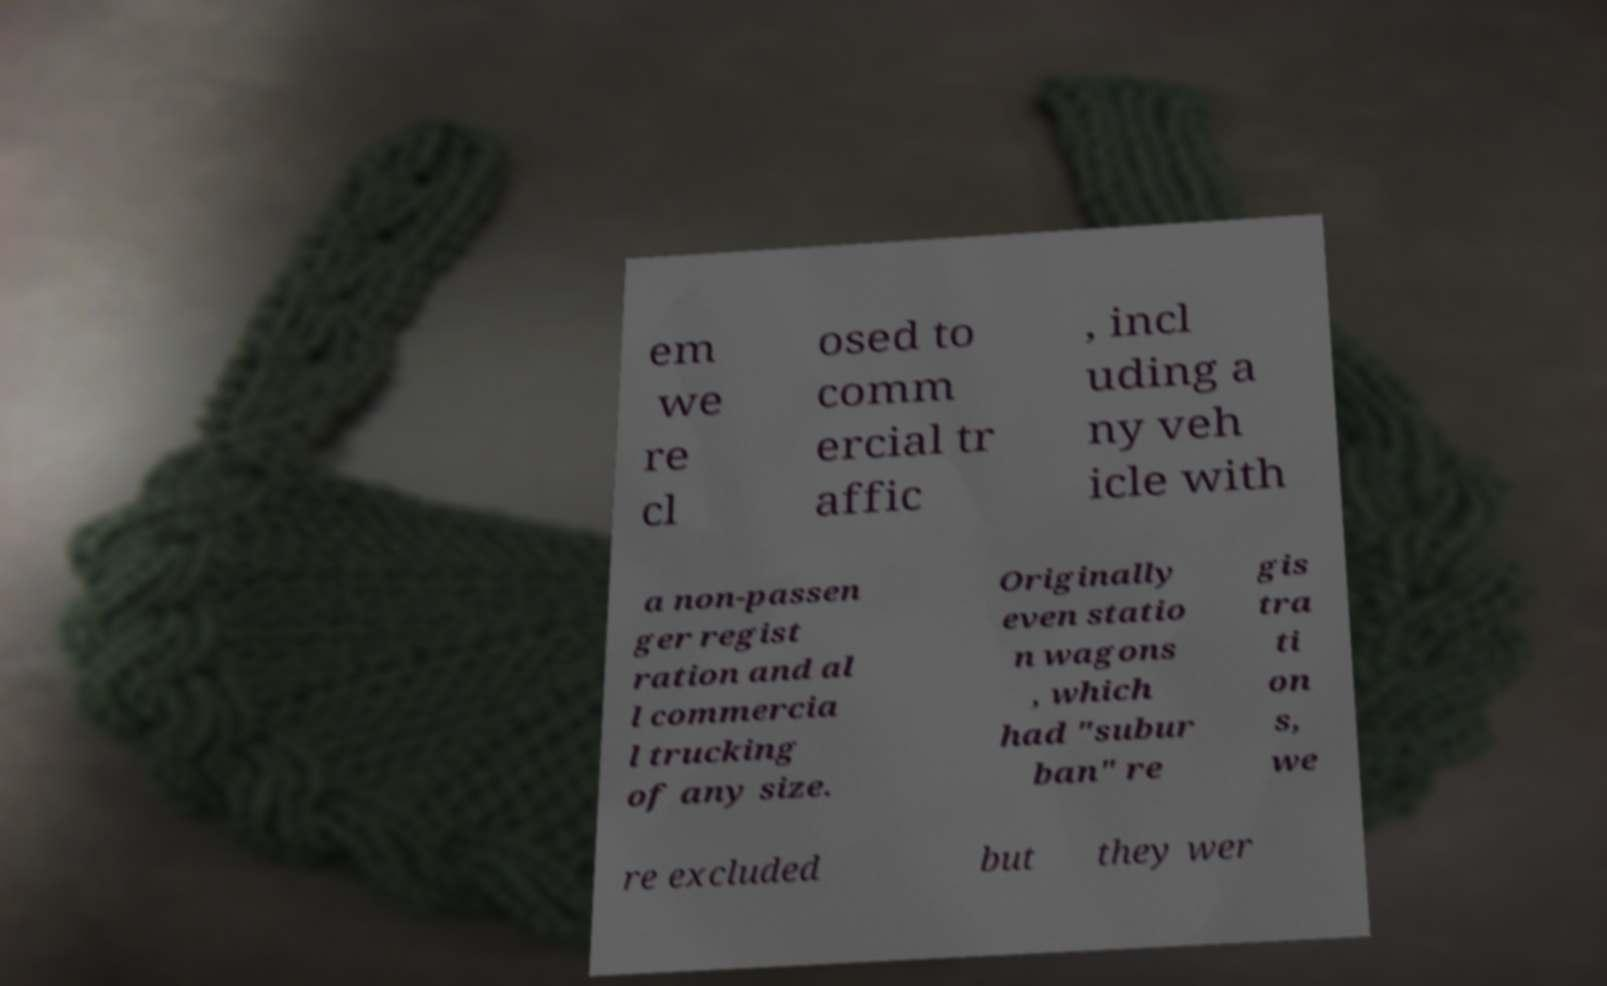Could you extract and type out the text from this image? em we re cl osed to comm ercial tr affic , incl uding a ny veh icle with a non-passen ger regist ration and al l commercia l trucking of any size. Originally even statio n wagons , which had "subur ban" re gis tra ti on s, we re excluded but they wer 